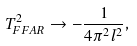<formula> <loc_0><loc_0><loc_500><loc_500>T ^ { 2 } _ { F F A R } \rightarrow - \frac { 1 } { 4 \pi ^ { 2 } l ^ { 2 } } ,</formula> 